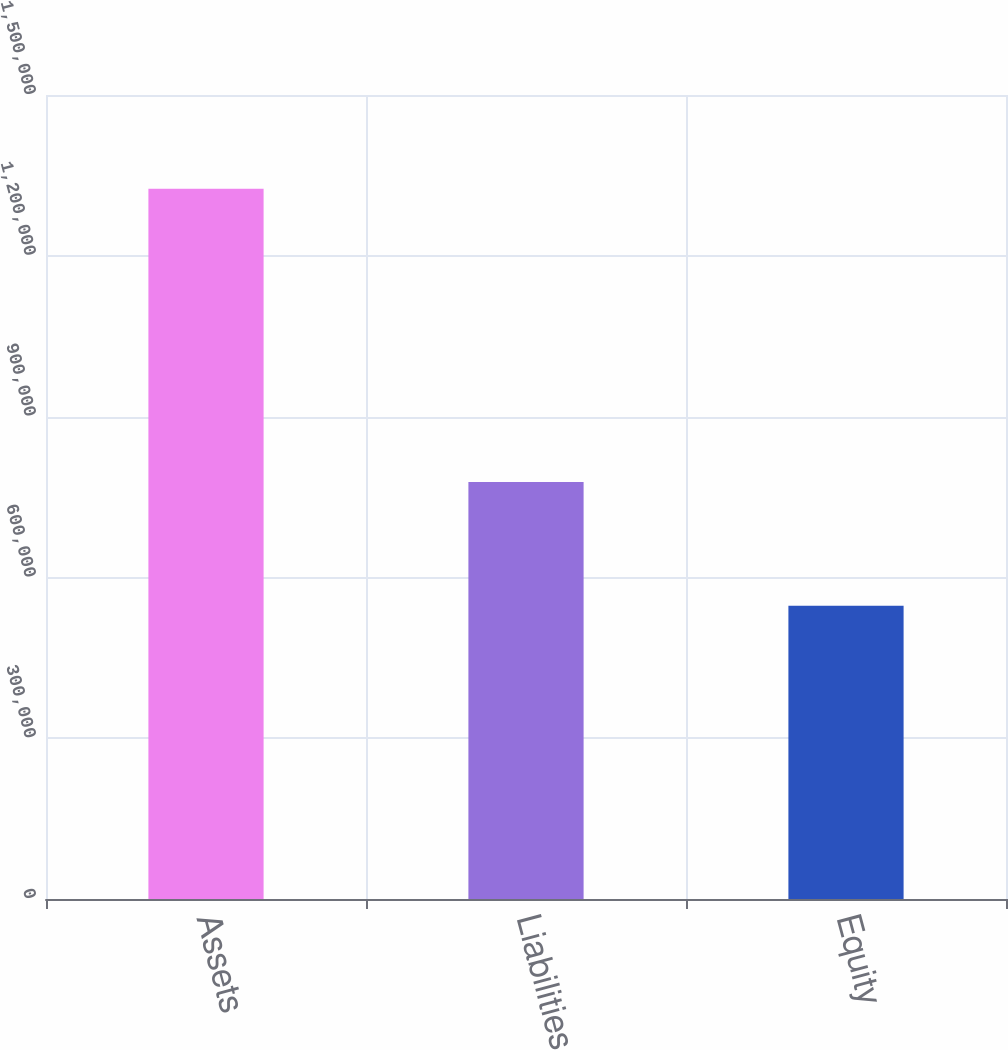Convert chart to OTSL. <chart><loc_0><loc_0><loc_500><loc_500><bar_chart><fcel>Assets<fcel>Liabilities<fcel>Equity<nl><fcel>1.32499e+06<fcel>777836<fcel>547157<nl></chart> 